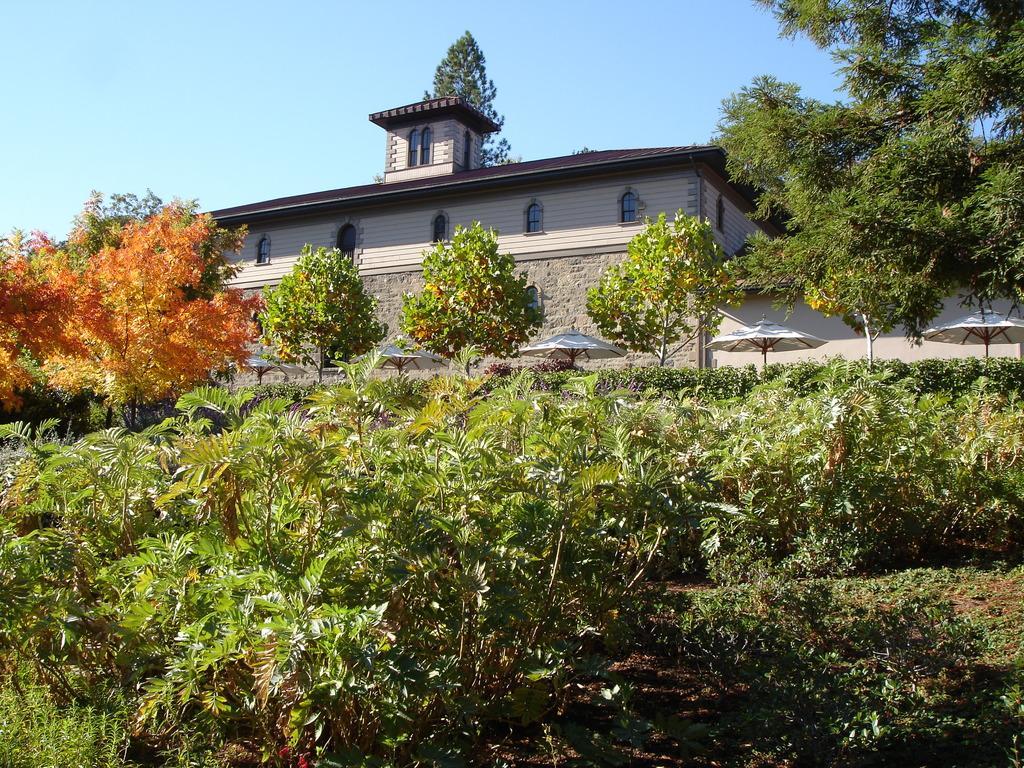Please provide a concise description of this image. In the center of the image, we can see a building and there are trees, umbrellas and plants. At the top, there is sky. 